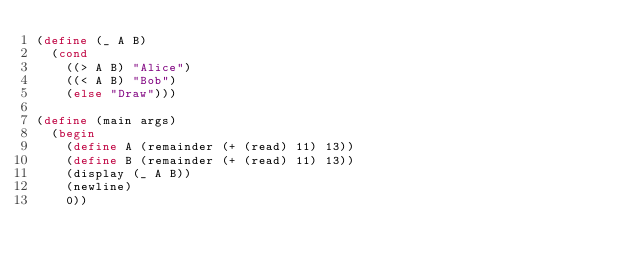Convert code to text. <code><loc_0><loc_0><loc_500><loc_500><_Scheme_>(define (_ A B)
  (cond
    ((> A B) "Alice")
    ((< A B) "Bob")
    (else "Draw")))

(define (main args)
  (begin
    (define A (remainder (+ (read) 11) 13))
    (define B (remainder (+ (read) 11) 13))
    (display (_ A B))
    (newline)
    0))</code> 